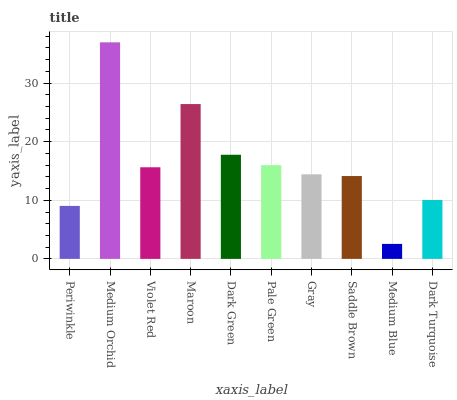Is Medium Blue the minimum?
Answer yes or no. Yes. Is Medium Orchid the maximum?
Answer yes or no. Yes. Is Violet Red the minimum?
Answer yes or no. No. Is Violet Red the maximum?
Answer yes or no. No. Is Medium Orchid greater than Violet Red?
Answer yes or no. Yes. Is Violet Red less than Medium Orchid?
Answer yes or no. Yes. Is Violet Red greater than Medium Orchid?
Answer yes or no. No. Is Medium Orchid less than Violet Red?
Answer yes or no. No. Is Violet Red the high median?
Answer yes or no. Yes. Is Gray the low median?
Answer yes or no. Yes. Is Pale Green the high median?
Answer yes or no. No. Is Pale Green the low median?
Answer yes or no. No. 